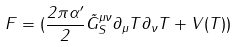<formula> <loc_0><loc_0><loc_500><loc_500>F = ( \frac { 2 \pi \alpha ^ { \prime } } { 2 } \tilde { G } _ { S } ^ { \mu \nu } \partial _ { \mu } T \partial _ { \nu } T + V ( T ) )</formula> 